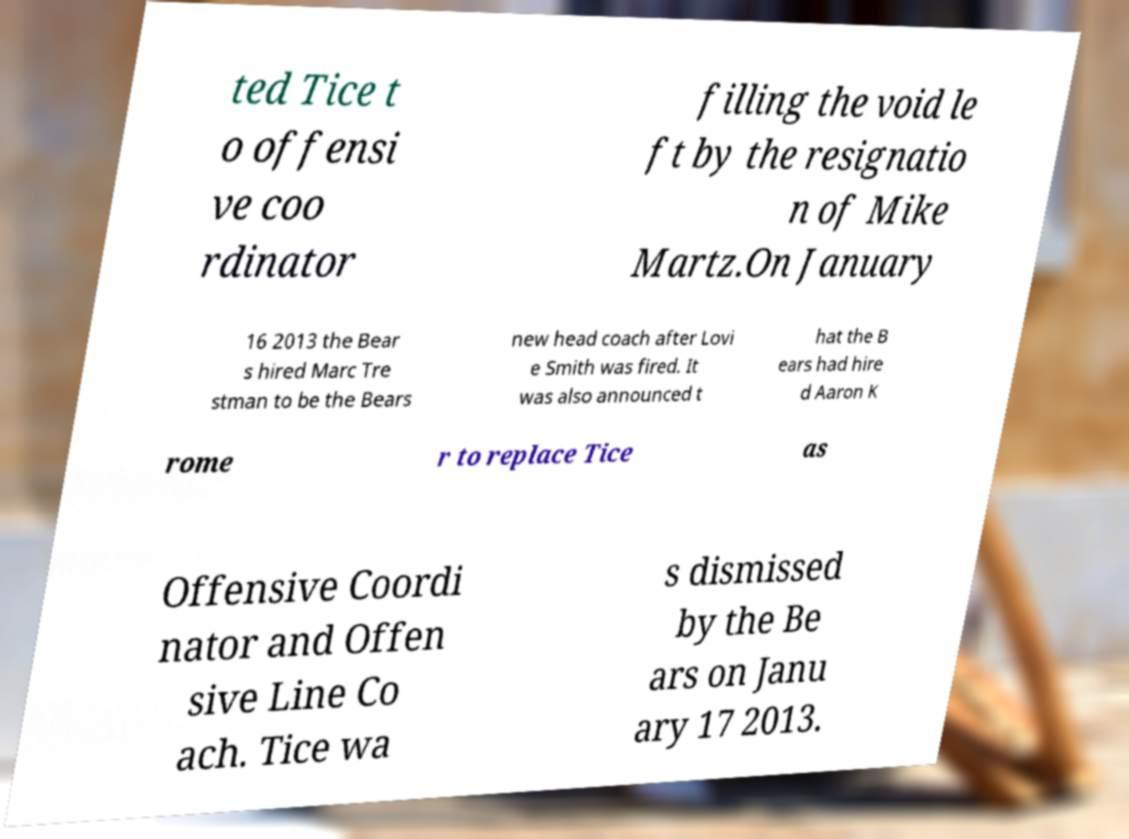For documentation purposes, I need the text within this image transcribed. Could you provide that? ted Tice t o offensi ve coo rdinator filling the void le ft by the resignatio n of Mike Martz.On January 16 2013 the Bear s hired Marc Tre stman to be the Bears new head coach after Lovi e Smith was fired. It was also announced t hat the B ears had hire d Aaron K rome r to replace Tice as Offensive Coordi nator and Offen sive Line Co ach. Tice wa s dismissed by the Be ars on Janu ary 17 2013. 